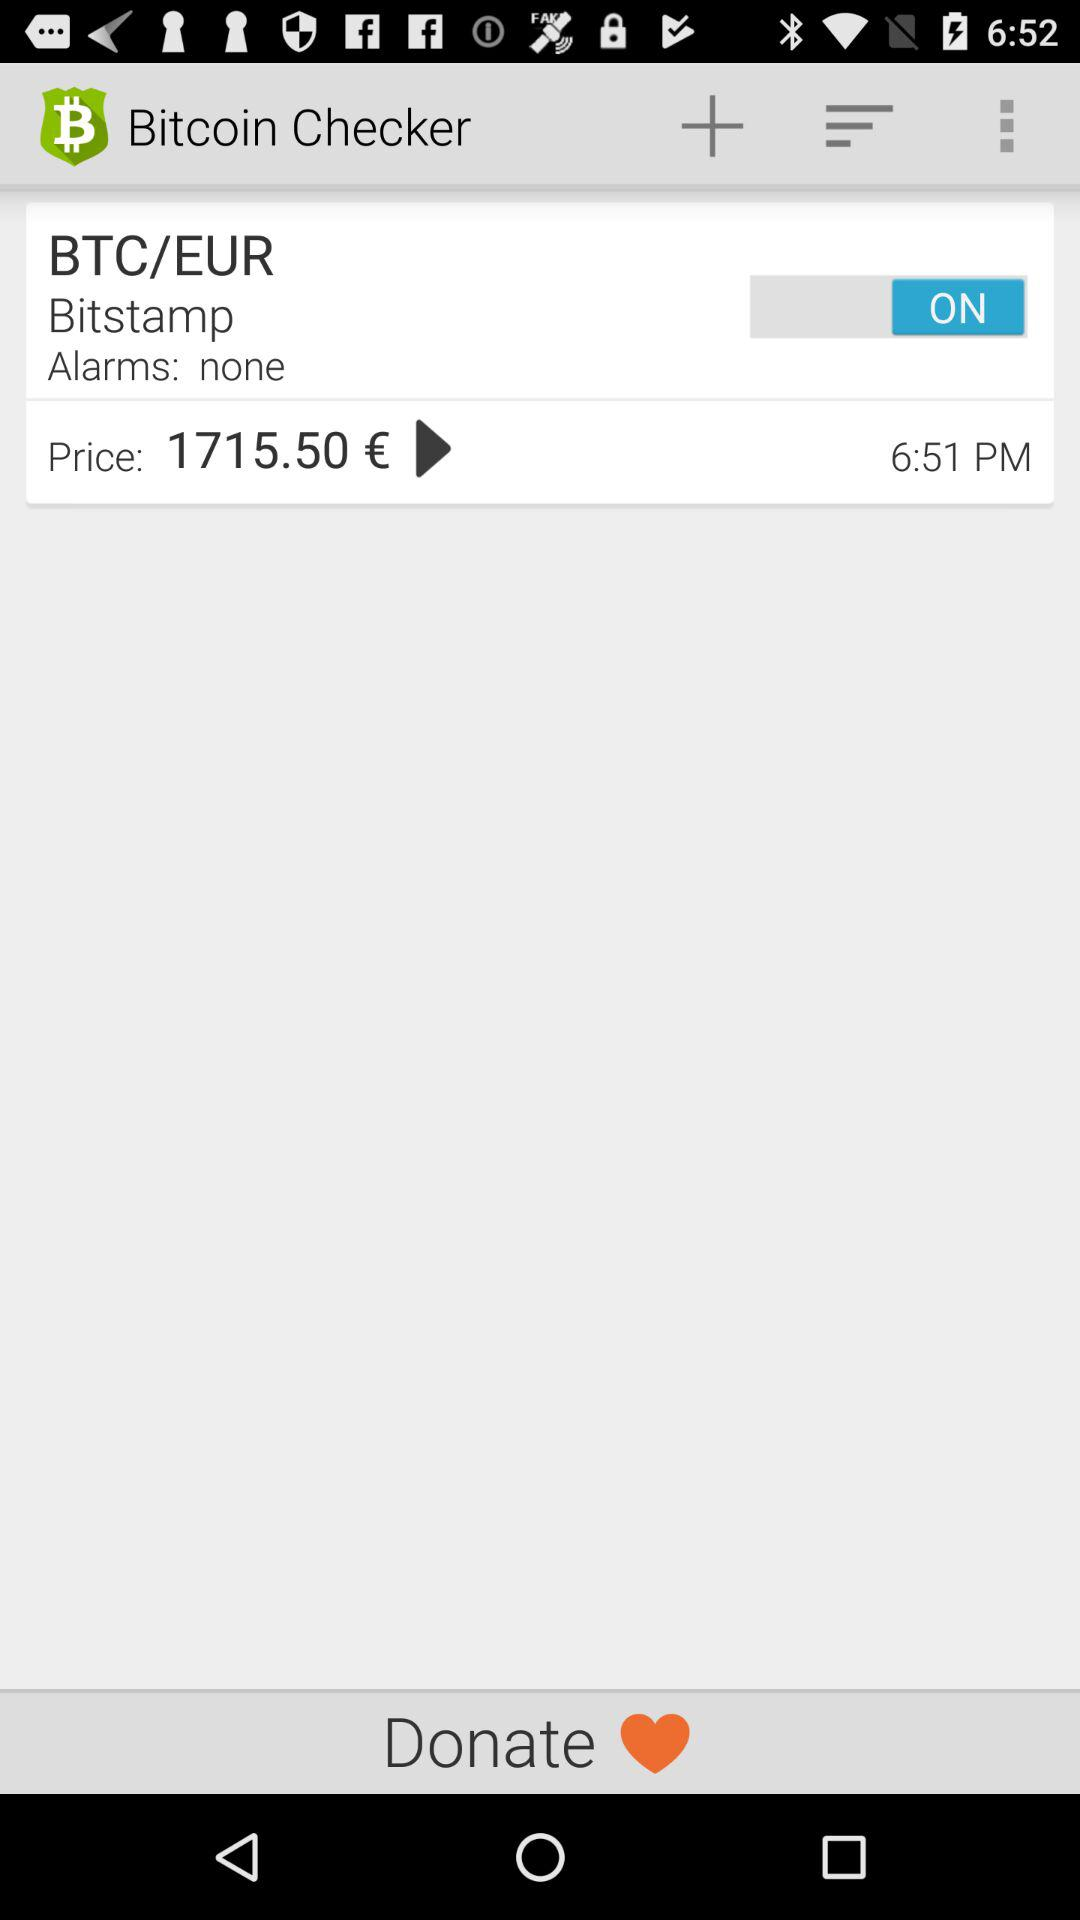What is the app name? The app name is "Bitcoin Checker". 